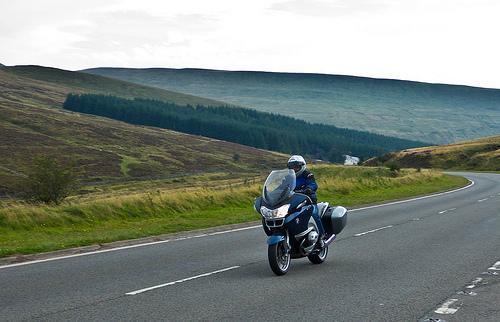How many people are there?
Give a very brief answer. 1. How many motorcycles are in the picture?
Give a very brief answer. 1. 